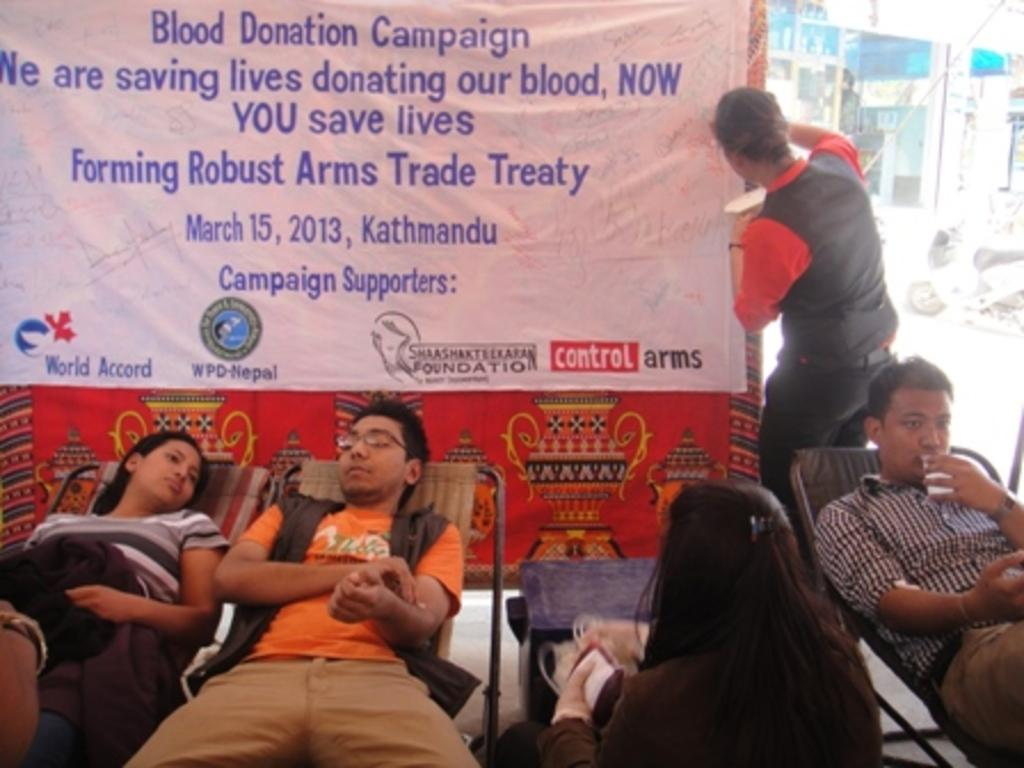What is the color of the banner in the image? The banner in the image is white. What type of structure can be seen in the image? There is a building in the image. Can you describe the people in the image? There are people in the image, and three of them are lying on chairs. What type of reaction can be seen from the crow in the image? There is no crow present in the image. Is the island visible in the image? There is no island present in the image. 